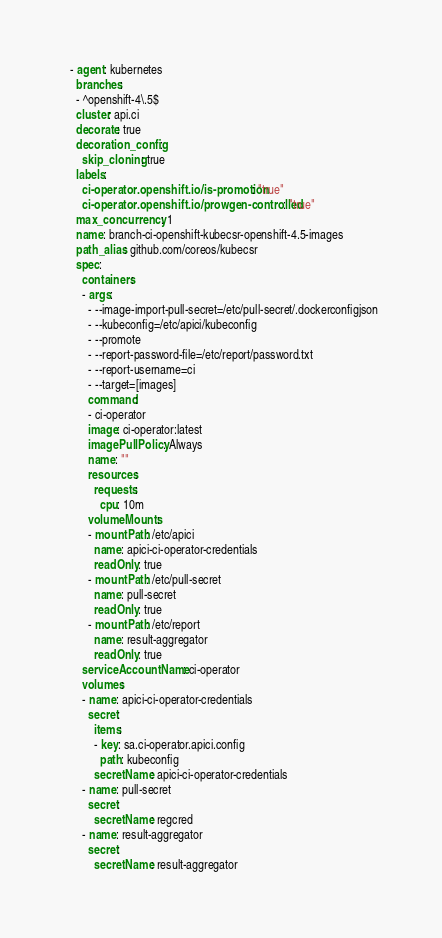<code> <loc_0><loc_0><loc_500><loc_500><_YAML_>  - agent: kubernetes
    branches:
    - ^openshift-4\.5$
    cluster: api.ci
    decorate: true
    decoration_config:
      skip_cloning: true
    labels:
      ci-operator.openshift.io/is-promotion: "true"
      ci-operator.openshift.io/prowgen-controlled: "true"
    max_concurrency: 1
    name: branch-ci-openshift-kubecsr-openshift-4.5-images
    path_alias: github.com/coreos/kubecsr
    spec:
      containers:
      - args:
        - --image-import-pull-secret=/etc/pull-secret/.dockerconfigjson
        - --kubeconfig=/etc/apici/kubeconfig
        - --promote
        - --report-password-file=/etc/report/password.txt
        - --report-username=ci
        - --target=[images]
        command:
        - ci-operator
        image: ci-operator:latest
        imagePullPolicy: Always
        name: ""
        resources:
          requests:
            cpu: 10m
        volumeMounts:
        - mountPath: /etc/apici
          name: apici-ci-operator-credentials
          readOnly: true
        - mountPath: /etc/pull-secret
          name: pull-secret
          readOnly: true
        - mountPath: /etc/report
          name: result-aggregator
          readOnly: true
      serviceAccountName: ci-operator
      volumes:
      - name: apici-ci-operator-credentials
        secret:
          items:
          - key: sa.ci-operator.apici.config
            path: kubeconfig
          secretName: apici-ci-operator-credentials
      - name: pull-secret
        secret:
          secretName: regcred
      - name: result-aggregator
        secret:
          secretName: result-aggregator
</code> 